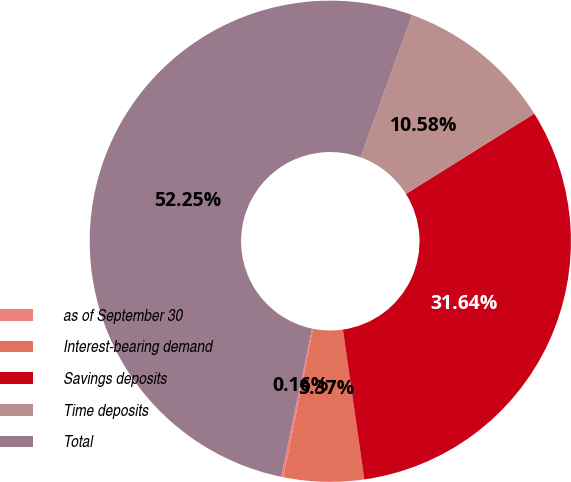Convert chart to OTSL. <chart><loc_0><loc_0><loc_500><loc_500><pie_chart><fcel>as of September 30<fcel>Interest-bearing demand<fcel>Savings deposits<fcel>Time deposits<fcel>Total<nl><fcel>0.16%<fcel>5.37%<fcel>31.64%<fcel>10.58%<fcel>52.25%<nl></chart> 